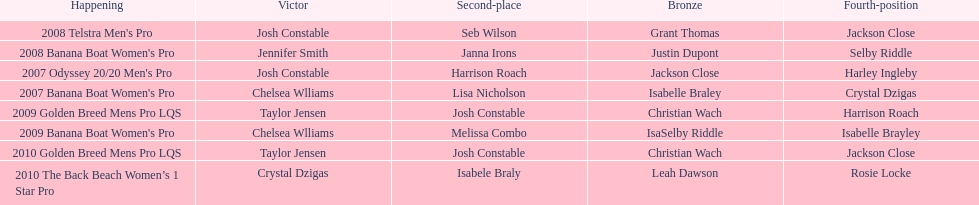Who was next to finish after josh constable in the 2008 telstra men's pro? Seb Wilson. 